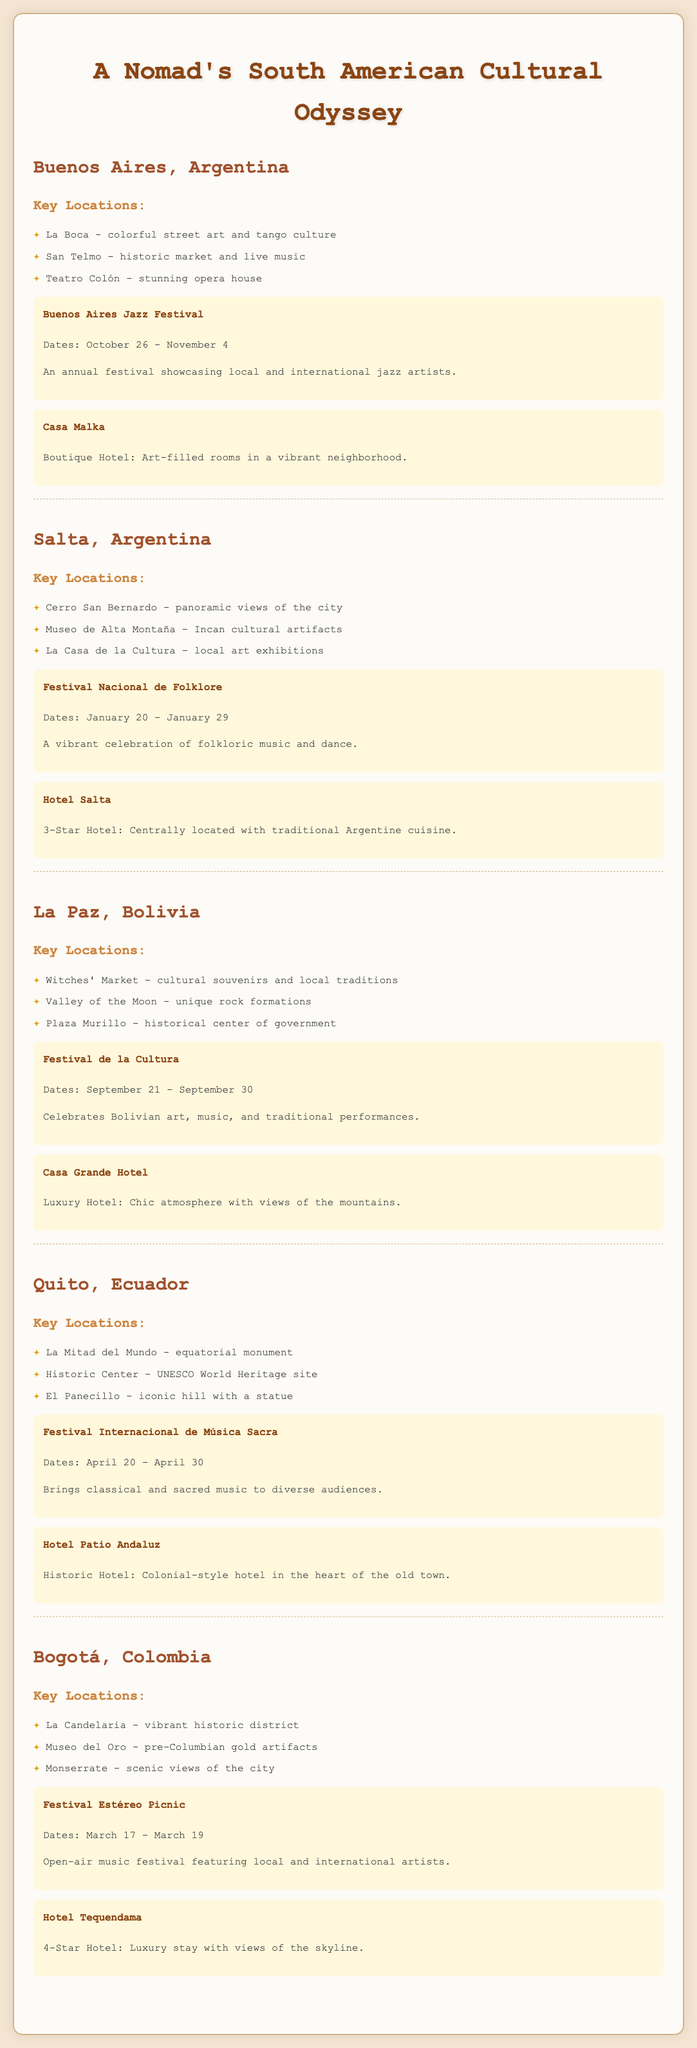What is the name of the festival in Buenos Aires? The festival mentioned in Buenos Aires is the Buenos Aires Jazz Festival.
Answer: Buenos Aires Jazz Festival When does the Festival Nacional de Folklore take place? The Festival Nacional de Folklore occurs from January 20 to January 29.
Answer: January 20 - January 29 What type of hotel is Casa Malka? Casa Malka is described as a boutique hotel with art-filled rooms.
Answer: Boutique Hotel Name a key location in La Paz. One of the key locations in La Paz is the Witches' Market.
Answer: Witches' Market Which city has a festival celebrating Bolivian art? The city that hosts a festival celebrating Bolivian art is La Paz.
Answer: La Paz What is the name of the historic hotel in Quito? The historic hotel in Quito is called Hotel Patio Andaluz.
Answer: Hotel Patio Andaluz What scenic view can be found in Bogotá? A scenic view in Bogotá can be found at Monserrate.
Answer: Monserrate What is a featured activity in San Telmo? A featured activity in San Telmo is live music.
Answer: Live music How long does the Festival Internacional de Música Sacra last? The Festival Internacional de Música Sacra lasts from April 20 to April 30.
Answer: April 20 - April 30 